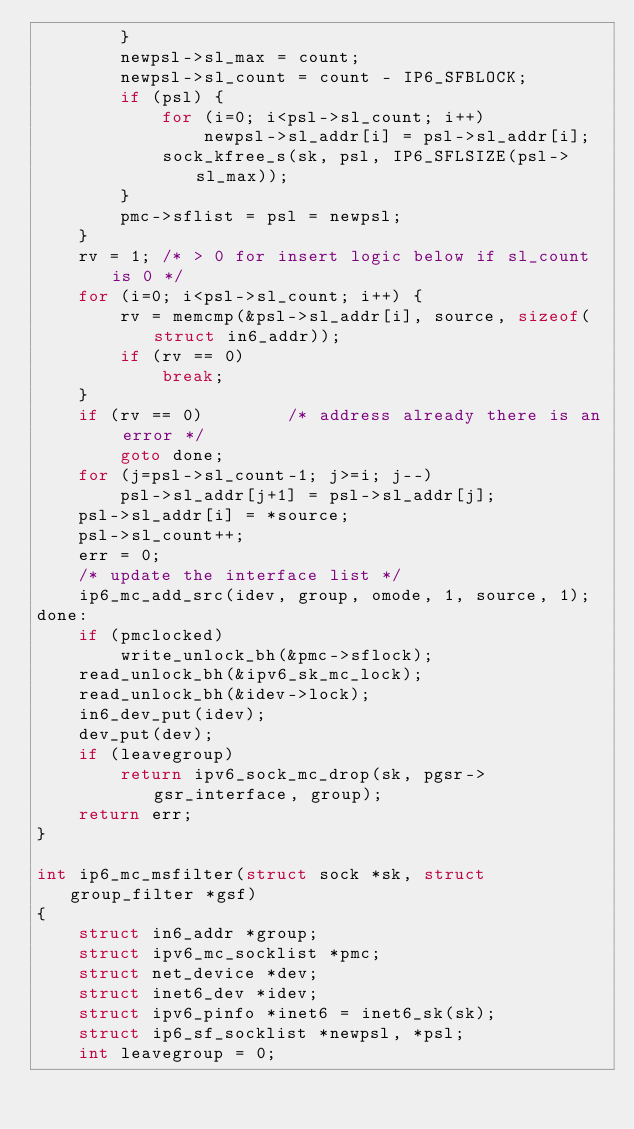<code> <loc_0><loc_0><loc_500><loc_500><_C_>		}
		newpsl->sl_max = count;
		newpsl->sl_count = count - IP6_SFBLOCK;
		if (psl) {
			for (i=0; i<psl->sl_count; i++)
				newpsl->sl_addr[i] = psl->sl_addr[i];
			sock_kfree_s(sk, psl, IP6_SFLSIZE(psl->sl_max));
		}
		pmc->sflist = psl = newpsl;
	}
	rv = 1;	/* > 0 for insert logic below if sl_count is 0 */
	for (i=0; i<psl->sl_count; i++) {
		rv = memcmp(&psl->sl_addr[i], source, sizeof(struct in6_addr));
		if (rv == 0)
			break;
	}
	if (rv == 0)		/* address already there is an error */
		goto done;
	for (j=psl->sl_count-1; j>=i; j--)
		psl->sl_addr[j+1] = psl->sl_addr[j];
	psl->sl_addr[i] = *source;
	psl->sl_count++;
	err = 0;
	/* update the interface list */
	ip6_mc_add_src(idev, group, omode, 1, source, 1);
done:
	if (pmclocked)
		write_unlock_bh(&pmc->sflock);
	read_unlock_bh(&ipv6_sk_mc_lock);
	read_unlock_bh(&idev->lock);
	in6_dev_put(idev);
	dev_put(dev);
	if (leavegroup)
		return ipv6_sock_mc_drop(sk, pgsr->gsr_interface, group);
	return err;
}

int ip6_mc_msfilter(struct sock *sk, struct group_filter *gsf)
{
	struct in6_addr *group;
	struct ipv6_mc_socklist *pmc;
	struct net_device *dev;
	struct inet6_dev *idev;
	struct ipv6_pinfo *inet6 = inet6_sk(sk);
	struct ip6_sf_socklist *newpsl, *psl;
	int leavegroup = 0;</code> 